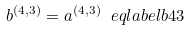Convert formula to latex. <formula><loc_0><loc_0><loc_500><loc_500>b ^ { ( 4 , 3 ) } = a ^ { ( 4 , 3 ) } \ e q l a b e l { b 4 3 }</formula> 